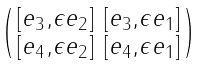Convert formula to latex. <formula><loc_0><loc_0><loc_500><loc_500>\begin{psmallmatrix} [ e _ { 3 } , \epsilon e _ { 2 } ] & [ e _ { 3 } , \epsilon e _ { 1 } ] \\ [ e _ { 4 } , \epsilon e _ { 2 } ] & [ e _ { 4 } , \epsilon e _ { 1 } ] \end{psmallmatrix}</formula> 